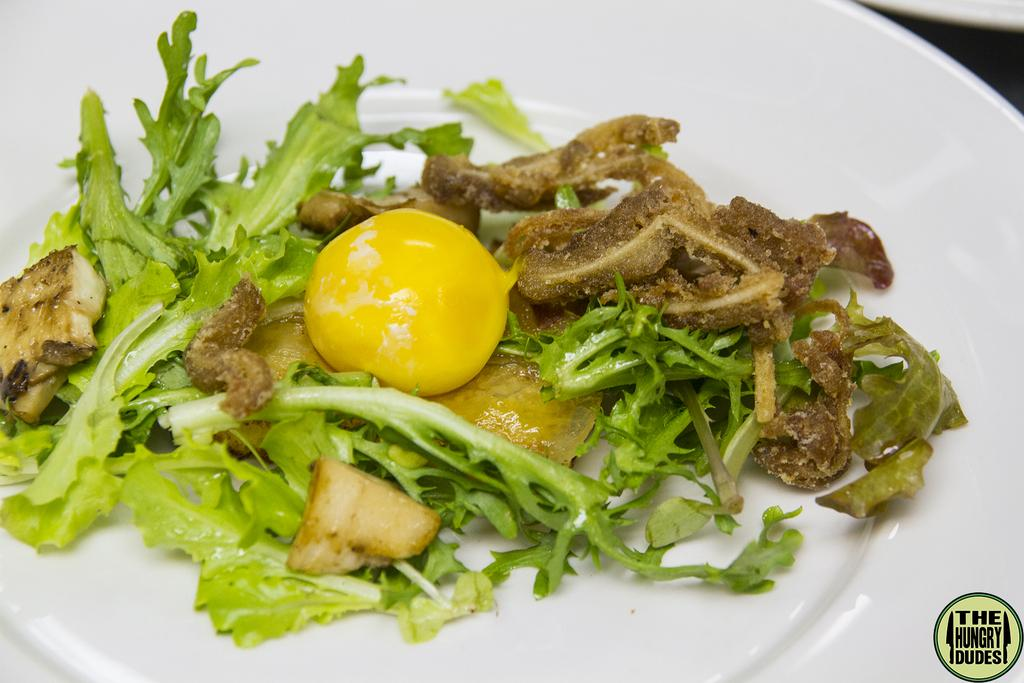What is present on the plate in the image? There is food on the plate in the image. Can you describe the plate itself? The facts provided do not give any details about the plate, so we cannot describe it further. What type of coast can be seen in the background of the image? There is no coast visible in the image; it only shows a plate with food on it. 